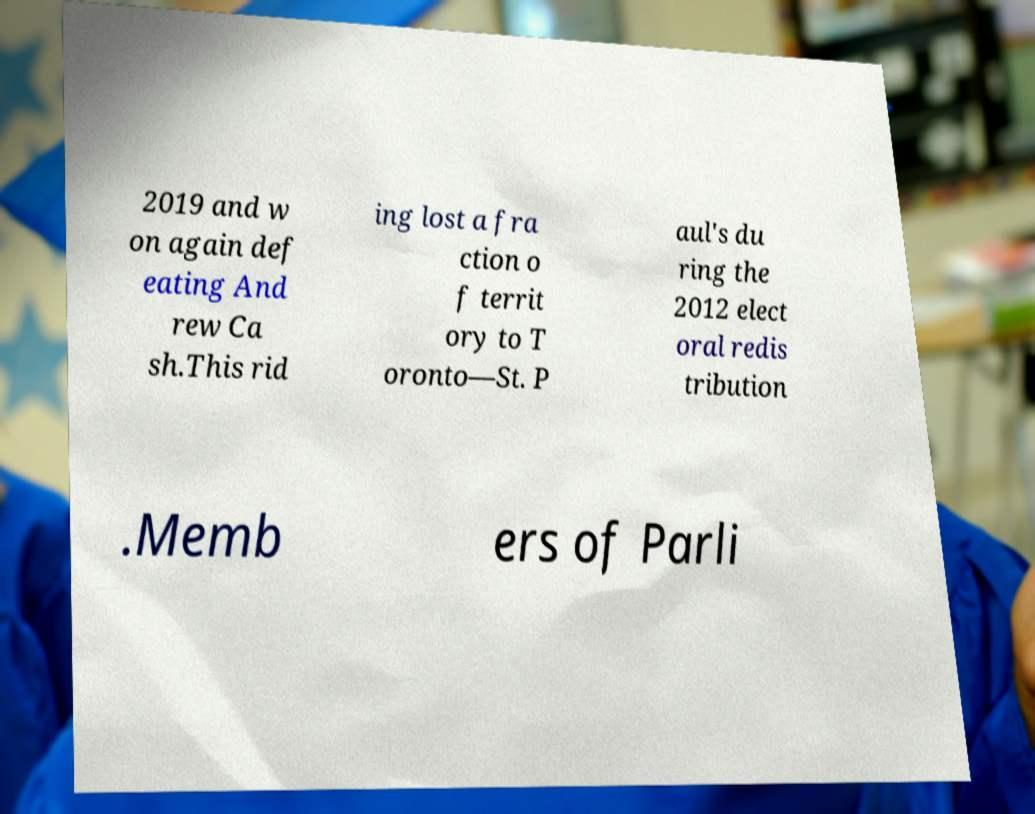Can you accurately transcribe the text from the provided image for me? 2019 and w on again def eating And rew Ca sh.This rid ing lost a fra ction o f territ ory to T oronto—St. P aul's du ring the 2012 elect oral redis tribution .Memb ers of Parli 